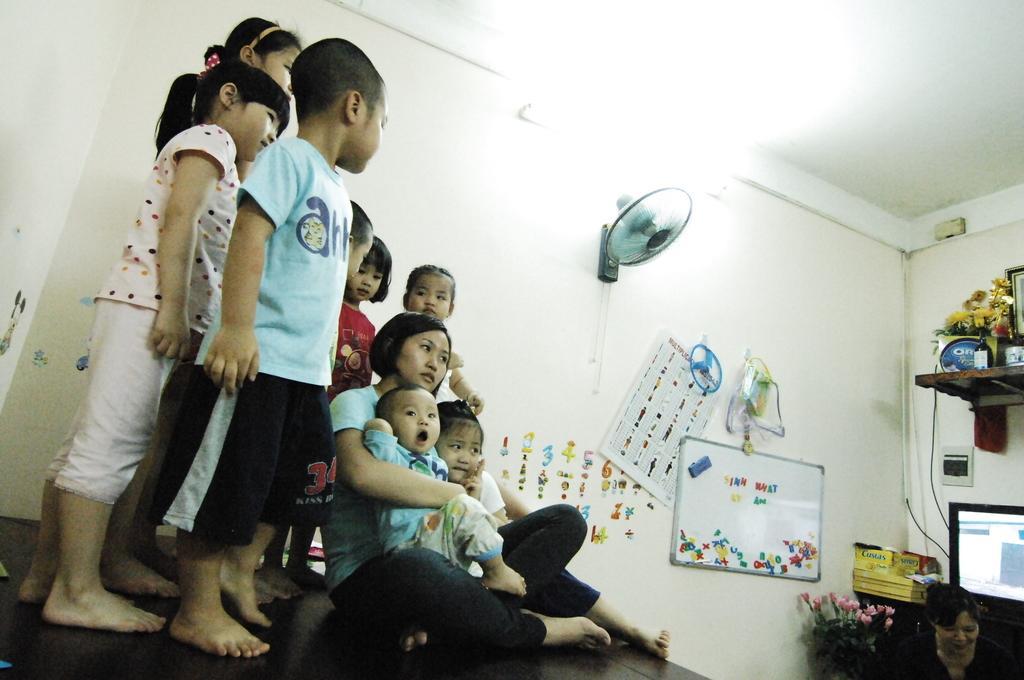Can you describe this image briefly? There are group of children in different color dresses standing on the bench. Beside them, there is a woman holding a baby and sitting on the table near another child who is sitting on the same table. On the right side, there is a woman near pot plant which is having flowers. In the background, there are stickers, posters, a fan which is attached to the wall, there are some objects on the shelf, there is a monitor and there are other objects. 